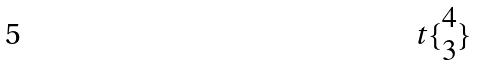Convert formula to latex. <formula><loc_0><loc_0><loc_500><loc_500>t \{ \begin{matrix} 4 \\ 3 \end{matrix} \}</formula> 